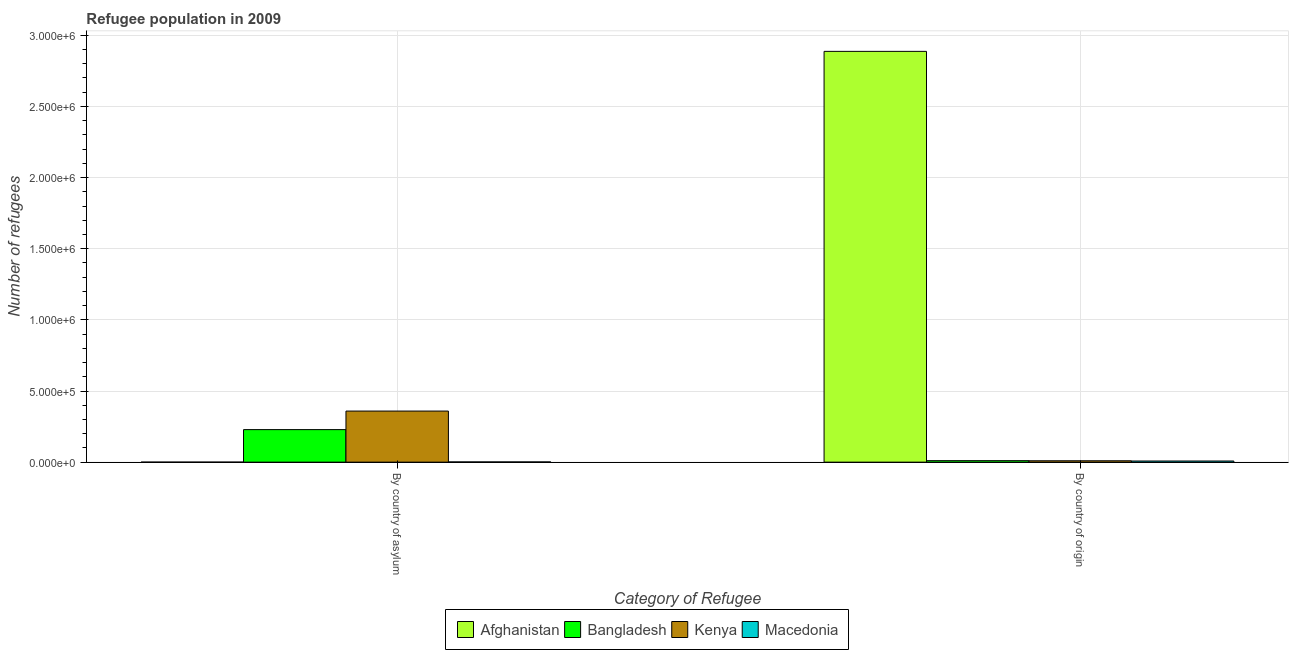Are the number of bars per tick equal to the number of legend labels?
Provide a succinct answer. Yes. What is the label of the 2nd group of bars from the left?
Ensure brevity in your answer.  By country of origin. What is the number of refugees by country of asylum in Kenya?
Provide a succinct answer. 3.59e+05. Across all countries, what is the maximum number of refugees by country of origin?
Make the answer very short. 2.89e+06. Across all countries, what is the minimum number of refugees by country of asylum?
Offer a terse response. 37. In which country was the number of refugees by country of asylum maximum?
Provide a short and direct response. Kenya. In which country was the number of refugees by country of origin minimum?
Provide a short and direct response. Macedonia. What is the total number of refugees by country of asylum in the graph?
Offer a very short reply. 5.89e+05. What is the difference between the number of refugees by country of asylum in Kenya and that in Macedonia?
Ensure brevity in your answer.  3.57e+05. What is the difference between the number of refugees by country of origin in Macedonia and the number of refugees by country of asylum in Bangladesh?
Provide a succinct answer. -2.21e+05. What is the average number of refugees by country of origin per country?
Your answer should be compact. 7.29e+05. What is the difference between the number of refugees by country of asylum and number of refugees by country of origin in Macedonia?
Make the answer very short. -6384. In how many countries, is the number of refugees by country of origin greater than 700000 ?
Provide a succinct answer. 1. What is the ratio of the number of refugees by country of asylum in Afghanistan to that in Bangladesh?
Give a very brief answer. 0. In how many countries, is the number of refugees by country of origin greater than the average number of refugees by country of origin taken over all countries?
Keep it short and to the point. 1. What does the 4th bar from the left in By country of asylum represents?
Make the answer very short. Macedonia. What does the 2nd bar from the right in By country of asylum represents?
Provide a succinct answer. Kenya. How many bars are there?
Offer a terse response. 8. Are all the bars in the graph horizontal?
Give a very brief answer. No. How many countries are there in the graph?
Offer a terse response. 4. Are the values on the major ticks of Y-axis written in scientific E-notation?
Provide a succinct answer. Yes. Does the graph contain grids?
Your response must be concise. Yes. Where does the legend appear in the graph?
Provide a succinct answer. Bottom center. How many legend labels are there?
Keep it short and to the point. 4. How are the legend labels stacked?
Make the answer very short. Horizontal. What is the title of the graph?
Provide a short and direct response. Refugee population in 2009. Does "Greece" appear as one of the legend labels in the graph?
Offer a very short reply. No. What is the label or title of the X-axis?
Provide a succinct answer. Category of Refugee. What is the label or title of the Y-axis?
Keep it short and to the point. Number of refugees. What is the Number of refugees of Bangladesh in By country of asylum?
Ensure brevity in your answer.  2.29e+05. What is the Number of refugees in Kenya in By country of asylum?
Provide a succinct answer. 3.59e+05. What is the Number of refugees in Macedonia in By country of asylum?
Ensure brevity in your answer.  1542. What is the Number of refugees of Afghanistan in By country of origin?
Your answer should be compact. 2.89e+06. What is the Number of refugees of Bangladesh in By country of origin?
Keep it short and to the point. 1.04e+04. What is the Number of refugees of Kenya in By country of origin?
Give a very brief answer. 9620. What is the Number of refugees of Macedonia in By country of origin?
Your answer should be very brief. 7926. Across all Category of Refugee, what is the maximum Number of refugees in Afghanistan?
Give a very brief answer. 2.89e+06. Across all Category of Refugee, what is the maximum Number of refugees in Bangladesh?
Provide a short and direct response. 2.29e+05. Across all Category of Refugee, what is the maximum Number of refugees in Kenya?
Your answer should be compact. 3.59e+05. Across all Category of Refugee, what is the maximum Number of refugees in Macedonia?
Provide a short and direct response. 7926. Across all Category of Refugee, what is the minimum Number of refugees in Afghanistan?
Your response must be concise. 37. Across all Category of Refugee, what is the minimum Number of refugees in Bangladesh?
Provide a short and direct response. 1.04e+04. Across all Category of Refugee, what is the minimum Number of refugees of Kenya?
Your answer should be very brief. 9620. Across all Category of Refugee, what is the minimum Number of refugees in Macedonia?
Offer a terse response. 1542. What is the total Number of refugees of Afghanistan in the graph?
Offer a terse response. 2.89e+06. What is the total Number of refugees of Bangladesh in the graph?
Provide a succinct answer. 2.39e+05. What is the total Number of refugees of Kenya in the graph?
Your response must be concise. 3.69e+05. What is the total Number of refugees in Macedonia in the graph?
Give a very brief answer. 9468. What is the difference between the Number of refugees in Afghanistan in By country of asylum and that in By country of origin?
Make the answer very short. -2.89e+06. What is the difference between the Number of refugees in Bangladesh in By country of asylum and that in By country of origin?
Your answer should be very brief. 2.18e+05. What is the difference between the Number of refugees in Kenya in By country of asylum and that in By country of origin?
Provide a succinct answer. 3.49e+05. What is the difference between the Number of refugees of Macedonia in By country of asylum and that in By country of origin?
Keep it short and to the point. -6384. What is the difference between the Number of refugees in Afghanistan in By country of asylum and the Number of refugees in Bangladesh in By country of origin?
Your response must be concise. -1.04e+04. What is the difference between the Number of refugees in Afghanistan in By country of asylum and the Number of refugees in Kenya in By country of origin?
Your answer should be very brief. -9583. What is the difference between the Number of refugees of Afghanistan in By country of asylum and the Number of refugees of Macedonia in By country of origin?
Offer a very short reply. -7889. What is the difference between the Number of refugees of Bangladesh in By country of asylum and the Number of refugees of Kenya in By country of origin?
Your answer should be compact. 2.19e+05. What is the difference between the Number of refugees in Bangladesh in By country of asylum and the Number of refugees in Macedonia in By country of origin?
Give a very brief answer. 2.21e+05. What is the difference between the Number of refugees in Kenya in By country of asylum and the Number of refugees in Macedonia in By country of origin?
Your answer should be very brief. 3.51e+05. What is the average Number of refugees in Afghanistan per Category of Refugee?
Ensure brevity in your answer.  1.44e+06. What is the average Number of refugees in Bangladesh per Category of Refugee?
Keep it short and to the point. 1.20e+05. What is the average Number of refugees in Kenya per Category of Refugee?
Give a very brief answer. 1.84e+05. What is the average Number of refugees in Macedonia per Category of Refugee?
Your answer should be very brief. 4734. What is the difference between the Number of refugees of Afghanistan and Number of refugees of Bangladesh in By country of asylum?
Your answer should be compact. -2.29e+05. What is the difference between the Number of refugees in Afghanistan and Number of refugees in Kenya in By country of asylum?
Offer a terse response. -3.59e+05. What is the difference between the Number of refugees in Afghanistan and Number of refugees in Macedonia in By country of asylum?
Provide a succinct answer. -1505. What is the difference between the Number of refugees in Bangladesh and Number of refugees in Kenya in By country of asylum?
Provide a short and direct response. -1.30e+05. What is the difference between the Number of refugees in Bangladesh and Number of refugees in Macedonia in By country of asylum?
Offer a terse response. 2.27e+05. What is the difference between the Number of refugees of Kenya and Number of refugees of Macedonia in By country of asylum?
Your answer should be compact. 3.57e+05. What is the difference between the Number of refugees of Afghanistan and Number of refugees of Bangladesh in By country of origin?
Make the answer very short. 2.88e+06. What is the difference between the Number of refugees of Afghanistan and Number of refugees of Kenya in By country of origin?
Keep it short and to the point. 2.88e+06. What is the difference between the Number of refugees in Afghanistan and Number of refugees in Macedonia in By country of origin?
Offer a terse response. 2.88e+06. What is the difference between the Number of refugees of Bangladesh and Number of refugees of Kenya in By country of origin?
Your answer should be very brief. 812. What is the difference between the Number of refugees in Bangladesh and Number of refugees in Macedonia in By country of origin?
Your response must be concise. 2506. What is the difference between the Number of refugees of Kenya and Number of refugees of Macedonia in By country of origin?
Offer a terse response. 1694. What is the ratio of the Number of refugees of Bangladesh in By country of asylum to that in By country of origin?
Give a very brief answer. 21.91. What is the ratio of the Number of refugees in Kenya in By country of asylum to that in By country of origin?
Provide a short and direct response. 37.31. What is the ratio of the Number of refugees of Macedonia in By country of asylum to that in By country of origin?
Keep it short and to the point. 0.19. What is the difference between the highest and the second highest Number of refugees in Afghanistan?
Offer a terse response. 2.89e+06. What is the difference between the highest and the second highest Number of refugees in Bangladesh?
Ensure brevity in your answer.  2.18e+05. What is the difference between the highest and the second highest Number of refugees in Kenya?
Keep it short and to the point. 3.49e+05. What is the difference between the highest and the second highest Number of refugees in Macedonia?
Make the answer very short. 6384. What is the difference between the highest and the lowest Number of refugees in Afghanistan?
Offer a very short reply. 2.89e+06. What is the difference between the highest and the lowest Number of refugees of Bangladesh?
Keep it short and to the point. 2.18e+05. What is the difference between the highest and the lowest Number of refugees of Kenya?
Your answer should be compact. 3.49e+05. What is the difference between the highest and the lowest Number of refugees in Macedonia?
Your answer should be compact. 6384. 